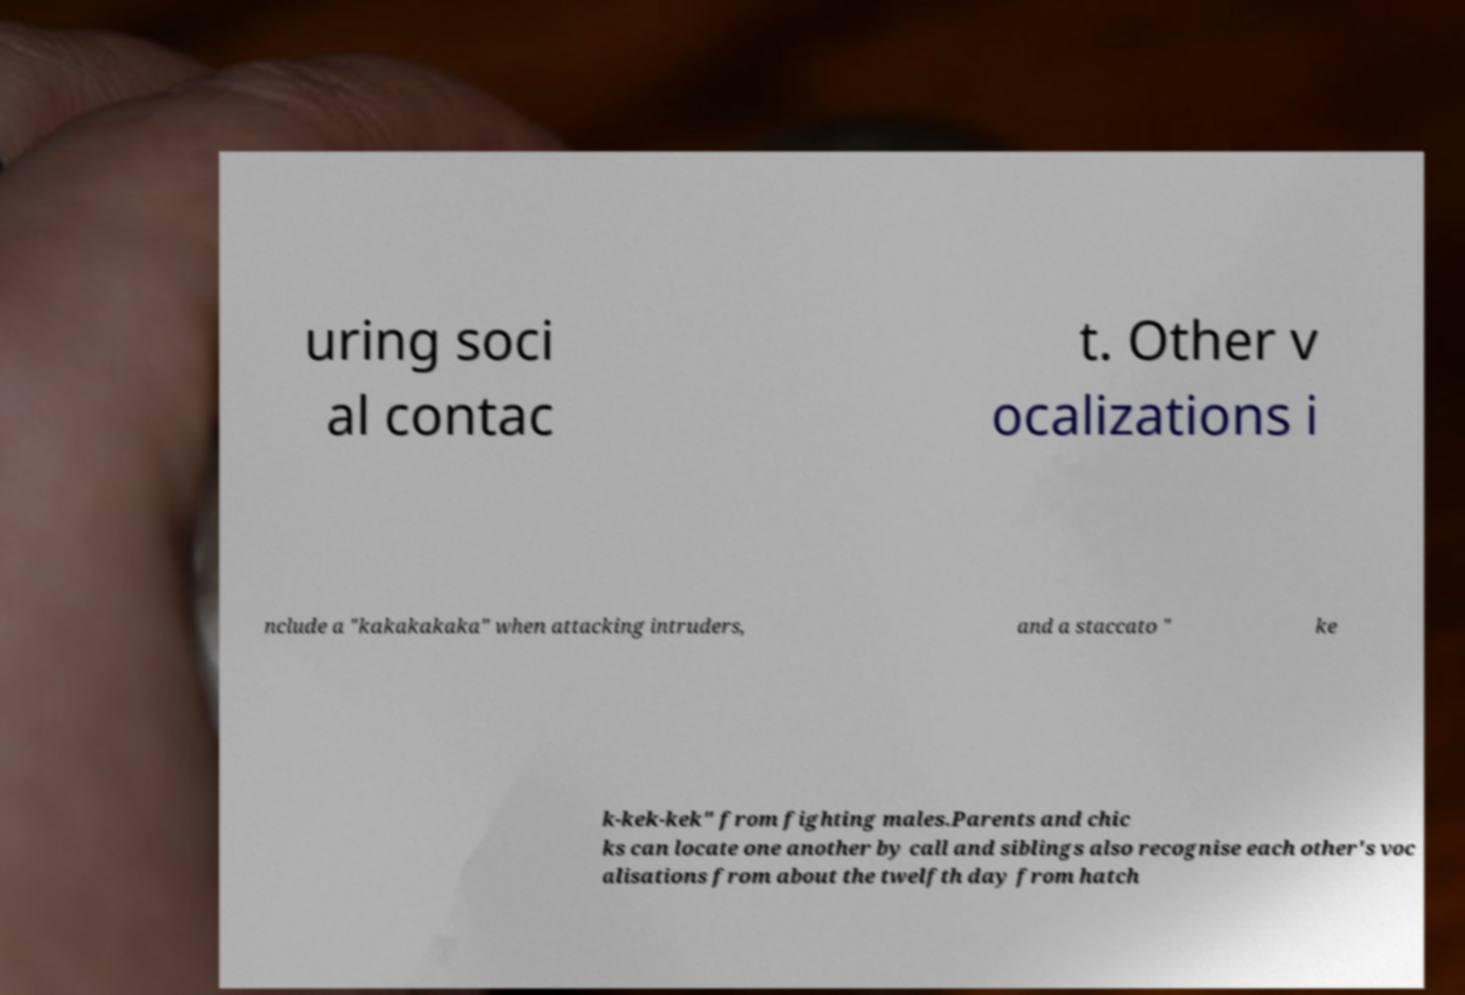Could you assist in decoding the text presented in this image and type it out clearly? uring soci al contac t. Other v ocalizations i nclude a "kakakakaka" when attacking intruders, and a staccato " ke k-kek-kek" from fighting males.Parents and chic ks can locate one another by call and siblings also recognise each other's voc alisations from about the twelfth day from hatch 